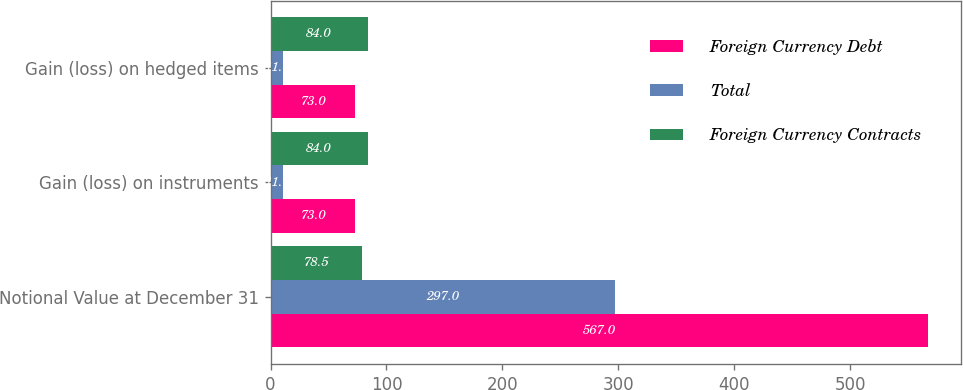Convert chart to OTSL. <chart><loc_0><loc_0><loc_500><loc_500><stacked_bar_chart><ecel><fcel>Notional Value at December 31<fcel>Gain (loss) on instruments<fcel>Gain (loss) on hedged items<nl><fcel>Foreign Currency Debt<fcel>567<fcel>73<fcel>73<nl><fcel>Total<fcel>297<fcel>11<fcel>11<nl><fcel>Foreign Currency Contracts<fcel>78.5<fcel>84<fcel>84<nl></chart> 